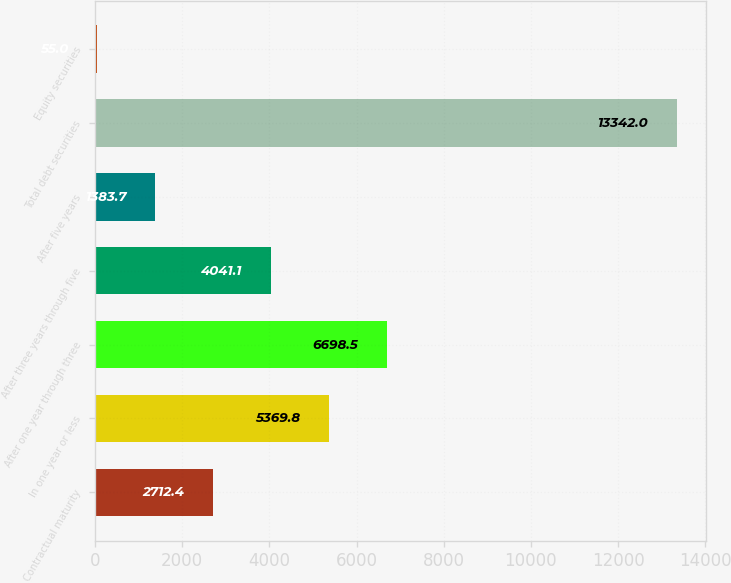<chart> <loc_0><loc_0><loc_500><loc_500><bar_chart><fcel>Contractual maturity<fcel>In one year or less<fcel>After one year through three<fcel>After three years through five<fcel>After five years<fcel>Total debt securities<fcel>Equity securities<nl><fcel>2712.4<fcel>5369.8<fcel>6698.5<fcel>4041.1<fcel>1383.7<fcel>13342<fcel>55<nl></chart> 